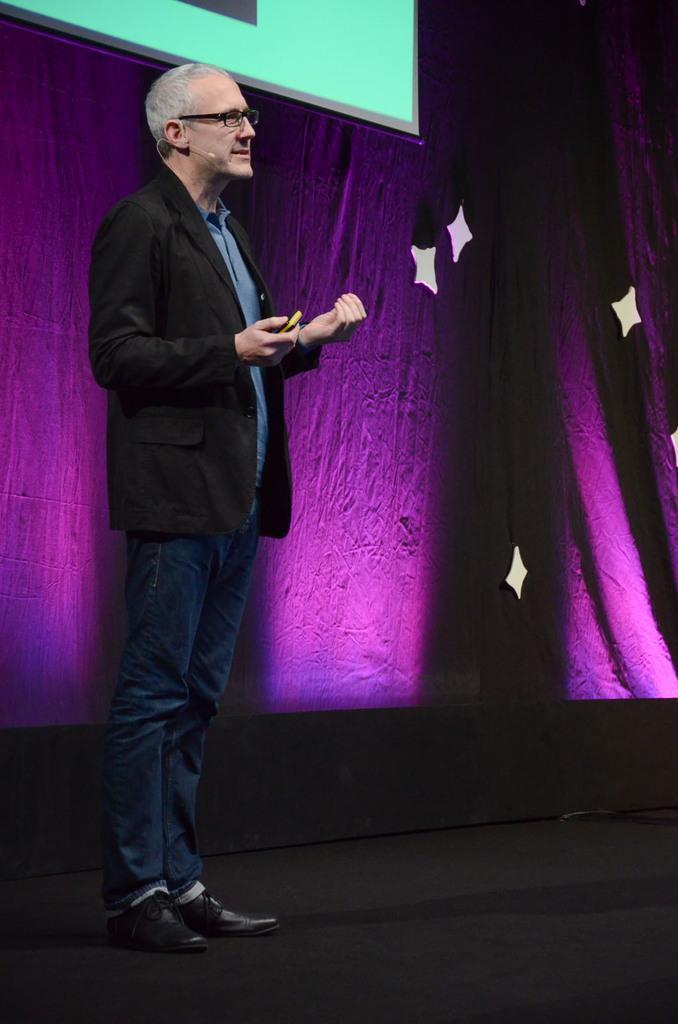Who is in the image? There is a person in the image. What is the person wearing? The person is wearing a suit. What is the person's posture in the image? The person is standing. What can be seen in the background of the image? There is a projector screen and a sheet in the background of the image. What type of writer is present in the image? There is no writer present in the image; it only features a person wearing a suit and standing. How does the person transport the sheet in the image? The person does not transport the sheet in the image; it is stationary in the background. 